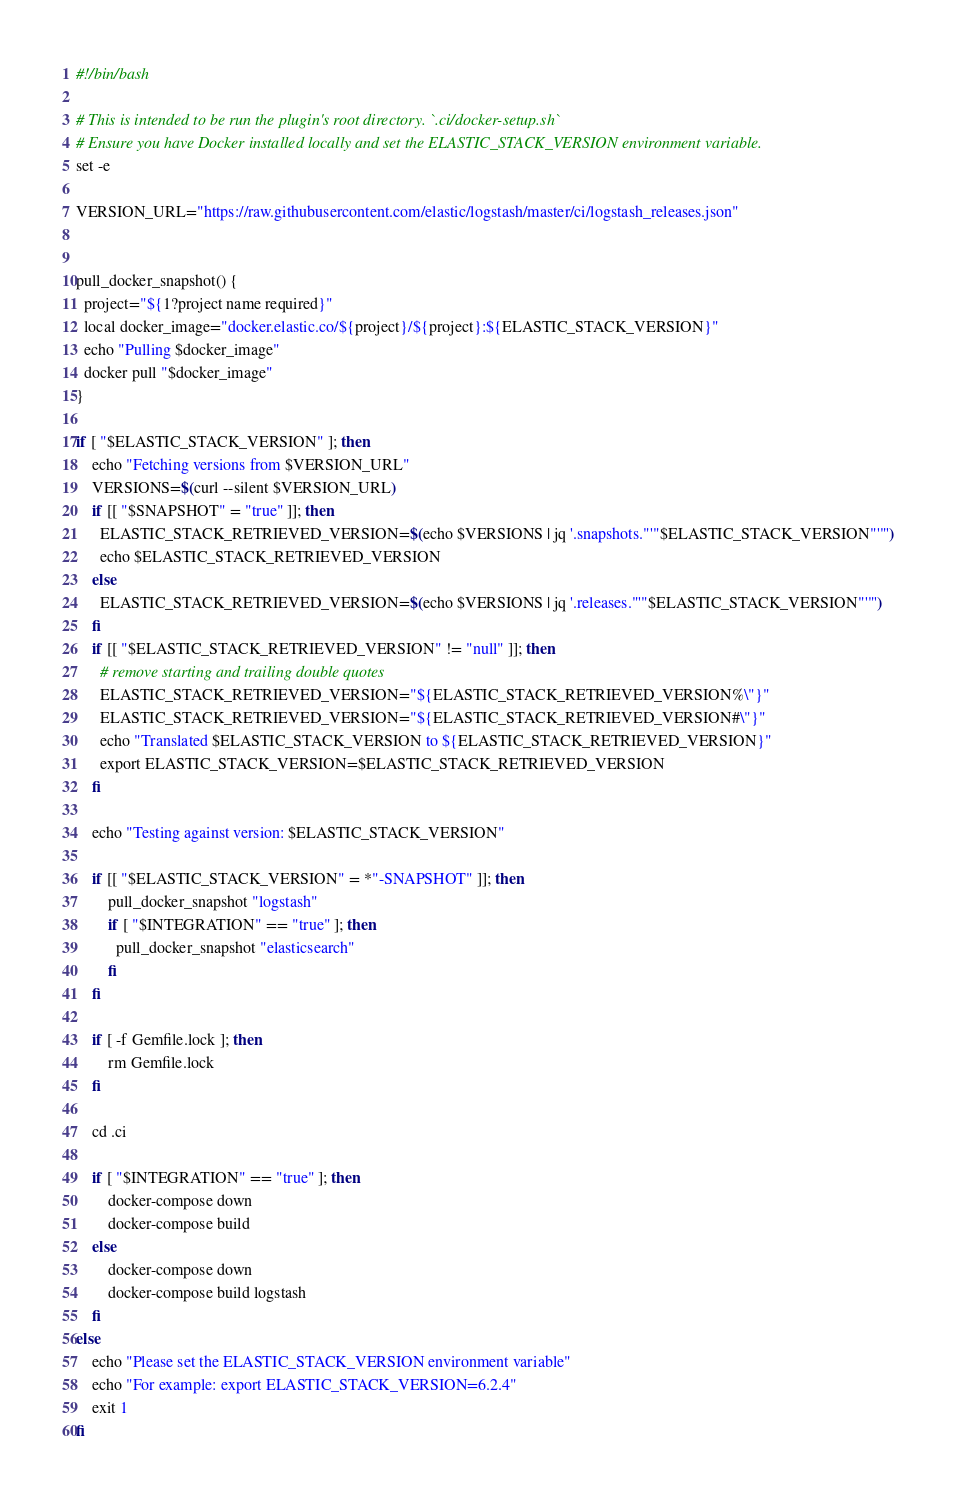Convert code to text. <code><loc_0><loc_0><loc_500><loc_500><_Bash_>#!/bin/bash

# This is intended to be run the plugin's root directory. `.ci/docker-setup.sh`
# Ensure you have Docker installed locally and set the ELASTIC_STACK_VERSION environment variable.
set -e

VERSION_URL="https://raw.githubusercontent.com/elastic/logstash/master/ci/logstash_releases.json"


pull_docker_snapshot() {
  project="${1?project name required}"
  local docker_image="docker.elastic.co/${project}/${project}:${ELASTIC_STACK_VERSION}"
  echo "Pulling $docker_image"
  docker pull "$docker_image"
}

if [ "$ELASTIC_STACK_VERSION" ]; then
    echo "Fetching versions from $VERSION_URL"
    VERSIONS=$(curl --silent $VERSION_URL)
    if [[ "$SNAPSHOT" = "true" ]]; then
      ELASTIC_STACK_RETRIEVED_VERSION=$(echo $VERSIONS | jq '.snapshots."'"$ELASTIC_STACK_VERSION"'"')
      echo $ELASTIC_STACK_RETRIEVED_VERSION
    else
      ELASTIC_STACK_RETRIEVED_VERSION=$(echo $VERSIONS | jq '.releases."'"$ELASTIC_STACK_VERSION"'"')
    fi
    if [[ "$ELASTIC_STACK_RETRIEVED_VERSION" != "null" ]]; then
      # remove starting and trailing double quotes
      ELASTIC_STACK_RETRIEVED_VERSION="${ELASTIC_STACK_RETRIEVED_VERSION%\"}"
      ELASTIC_STACK_RETRIEVED_VERSION="${ELASTIC_STACK_RETRIEVED_VERSION#\"}"
      echo "Translated $ELASTIC_STACK_VERSION to ${ELASTIC_STACK_RETRIEVED_VERSION}"
      export ELASTIC_STACK_VERSION=$ELASTIC_STACK_RETRIEVED_VERSION
    fi

    echo "Testing against version: $ELASTIC_STACK_VERSION"

    if [[ "$ELASTIC_STACK_VERSION" = *"-SNAPSHOT" ]]; then
        pull_docker_snapshot "logstash"
        if [ "$INTEGRATION" == "true" ]; then
          pull_docker_snapshot "elasticsearch"
        fi
    fi

    if [ -f Gemfile.lock ]; then
        rm Gemfile.lock
    fi

    cd .ci

    if [ "$INTEGRATION" == "true" ]; then
        docker-compose down
        docker-compose build
    else
        docker-compose down
        docker-compose build logstash
    fi
else
    echo "Please set the ELASTIC_STACK_VERSION environment variable"
    echo "For example: export ELASTIC_STACK_VERSION=6.2.4"
    exit 1
fi

</code> 